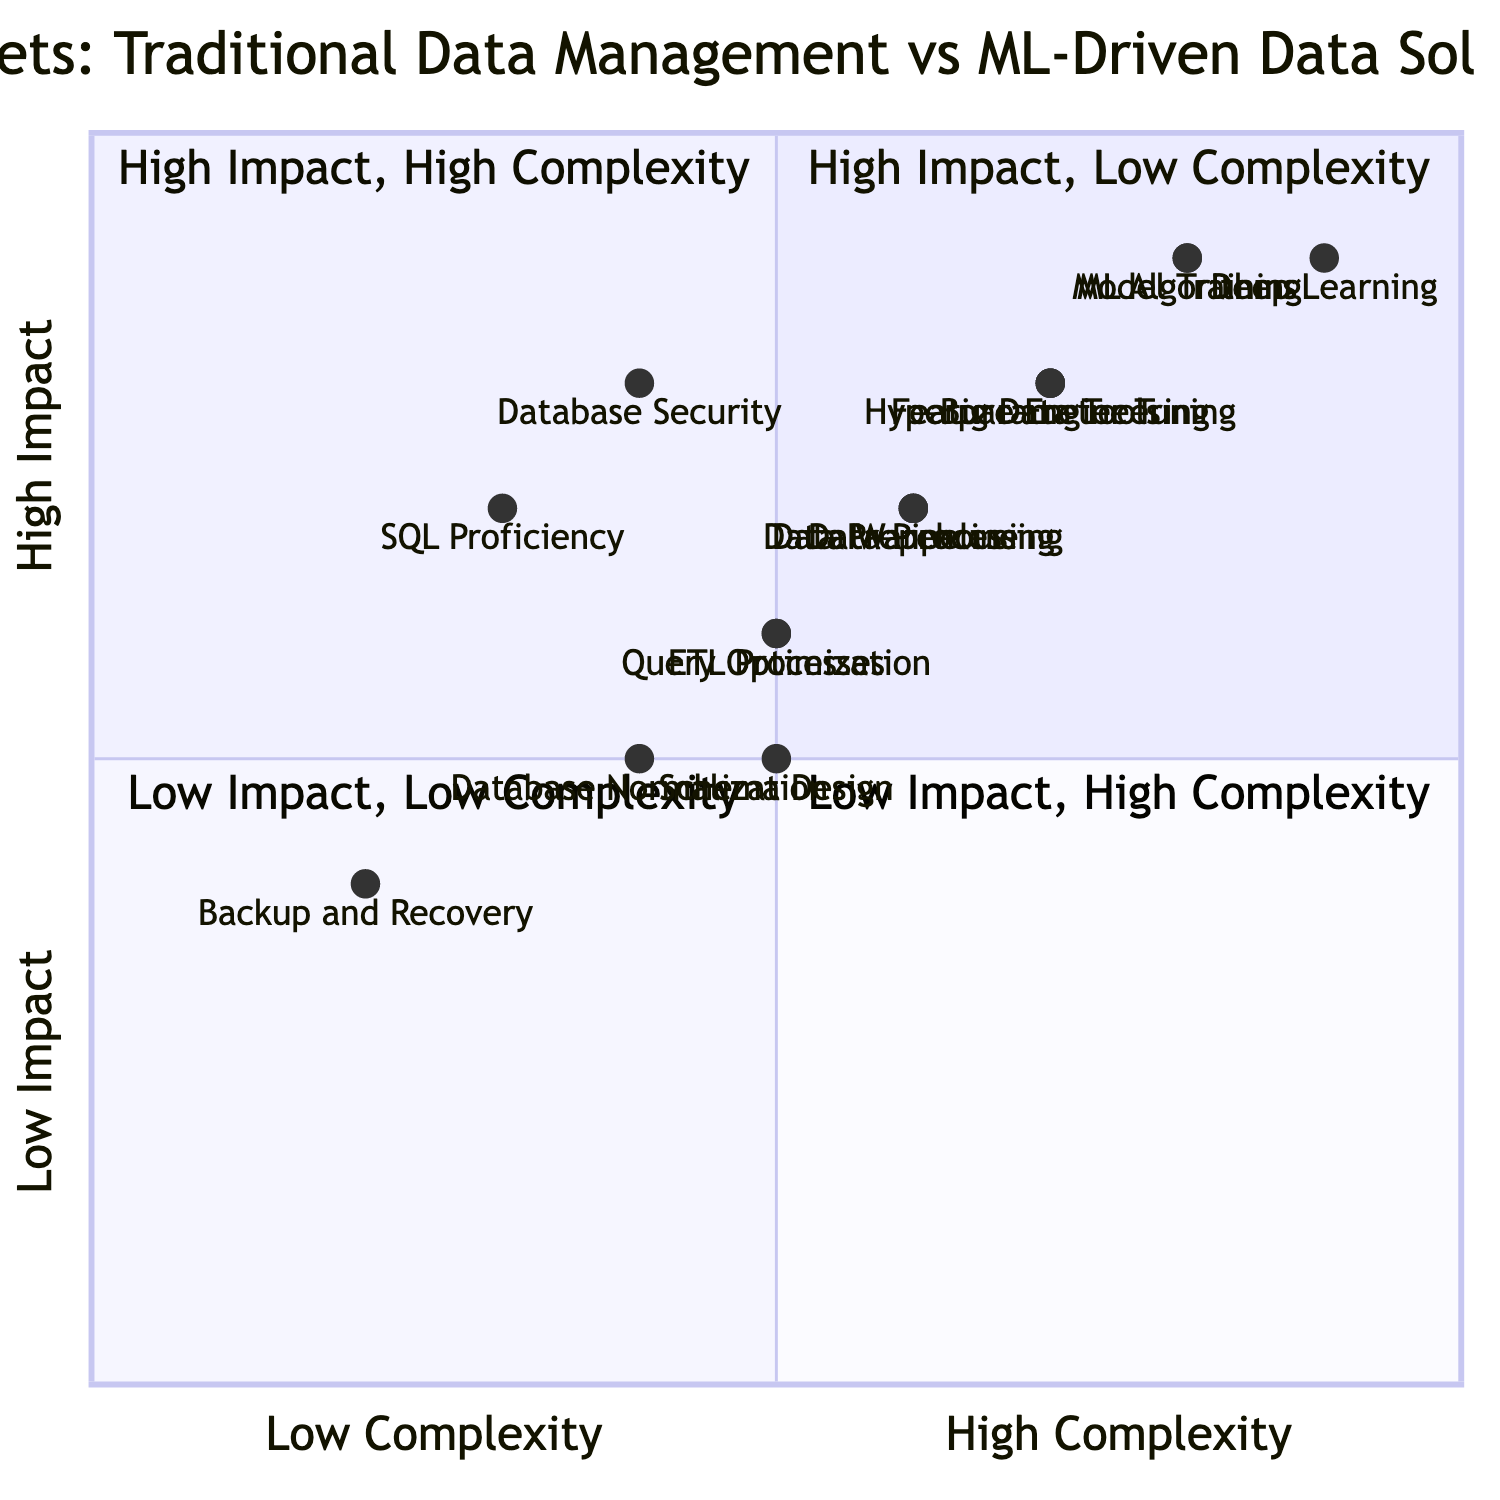What skill has the highest impact? The skill with the highest impact is "Deep Learning" which is located in quadrant 2 with coordinates [0.9, 0.9].
Answer: Deep Learning Which skill is placed in quadrant 1? In quadrant 1, "SQL Proficiency" is present, with coordinates [0.3, 0.7]. This means it has high impact and low complexity.
Answer: SQL Proficiency What is the total number of skills represented in the diagram? There are 16 skills in total when considering both categories: 8 from Traditional Data Management and 8 from ML-Driven Data Solutions.
Answer: 16 Which skill has the lowest complexity? "Backup and Recovery" has the lowest complexity in this diagram, with coordinates [0.2, 0.4].
Answer: Backup and Recovery Which skill is located in quadrant 4? The skill in quadrant 4 is "Schema Design", located at [0.5, 0.5] which indicates low impact and high complexity.
Answer: Schema Design Which two skills have a similar impact level but differing complexities? "Data Warehouse" and "Data Pipeline Automation" both have an impact level of around 0.7, but differ in complexity: Data Warehouse has [0.6, 0.7] and Data Pipeline Automation has [0.6, 0.7].
Answer: Data Warehouse and Data Pipeline Automation What is the impact value of “Feature Engineering”? The impact value of "Feature Engineering" is 0.8, as depicted in quadrant 2 where it is positioned at [0.7, 0.8].
Answer: 0.8 In terms of impact, which skill is ranked second after "Deep Learning"? "Model Training" is the second-ranking skill in impact after "Deep Learning," with a value of [0.8, 0.9]. This indicates it has a similar high impact level.
Answer: Model Training Which quadrant contains the most skills? Quadrant 2 contains the most skills with four skills located in that area: "Deep Learning", "Model Training", "ML Algorithms", and "Feature Engineering".
Answer: Quadrant 2 